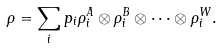Convert formula to latex. <formula><loc_0><loc_0><loc_500><loc_500>\rho = \sum _ { i } p _ { i } \rho _ { i } ^ { A } \otimes \rho _ { i } ^ { B } \otimes \dots \otimes \rho _ { i } ^ { W } .</formula> 